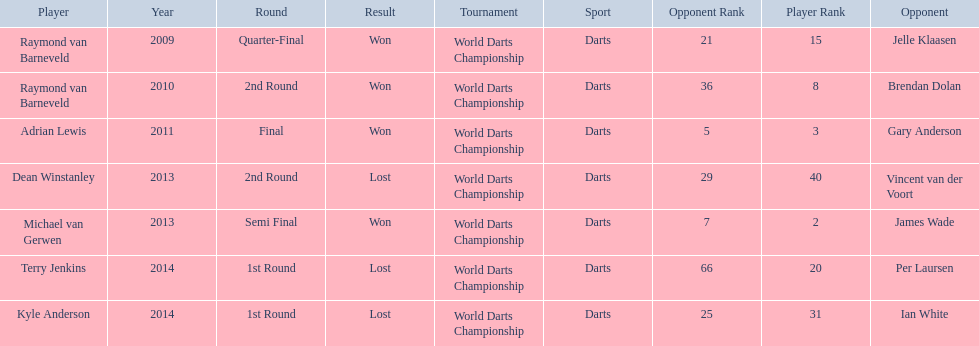Who are the players at the pdc world darts championship? Raymond van Barneveld, Raymond van Barneveld, Adrian Lewis, Dean Winstanley, Michael van Gerwen, Terry Jenkins, Kyle Anderson. When did kyle anderson lose? 2014. Which other players lost in 2014? Terry Jenkins. 